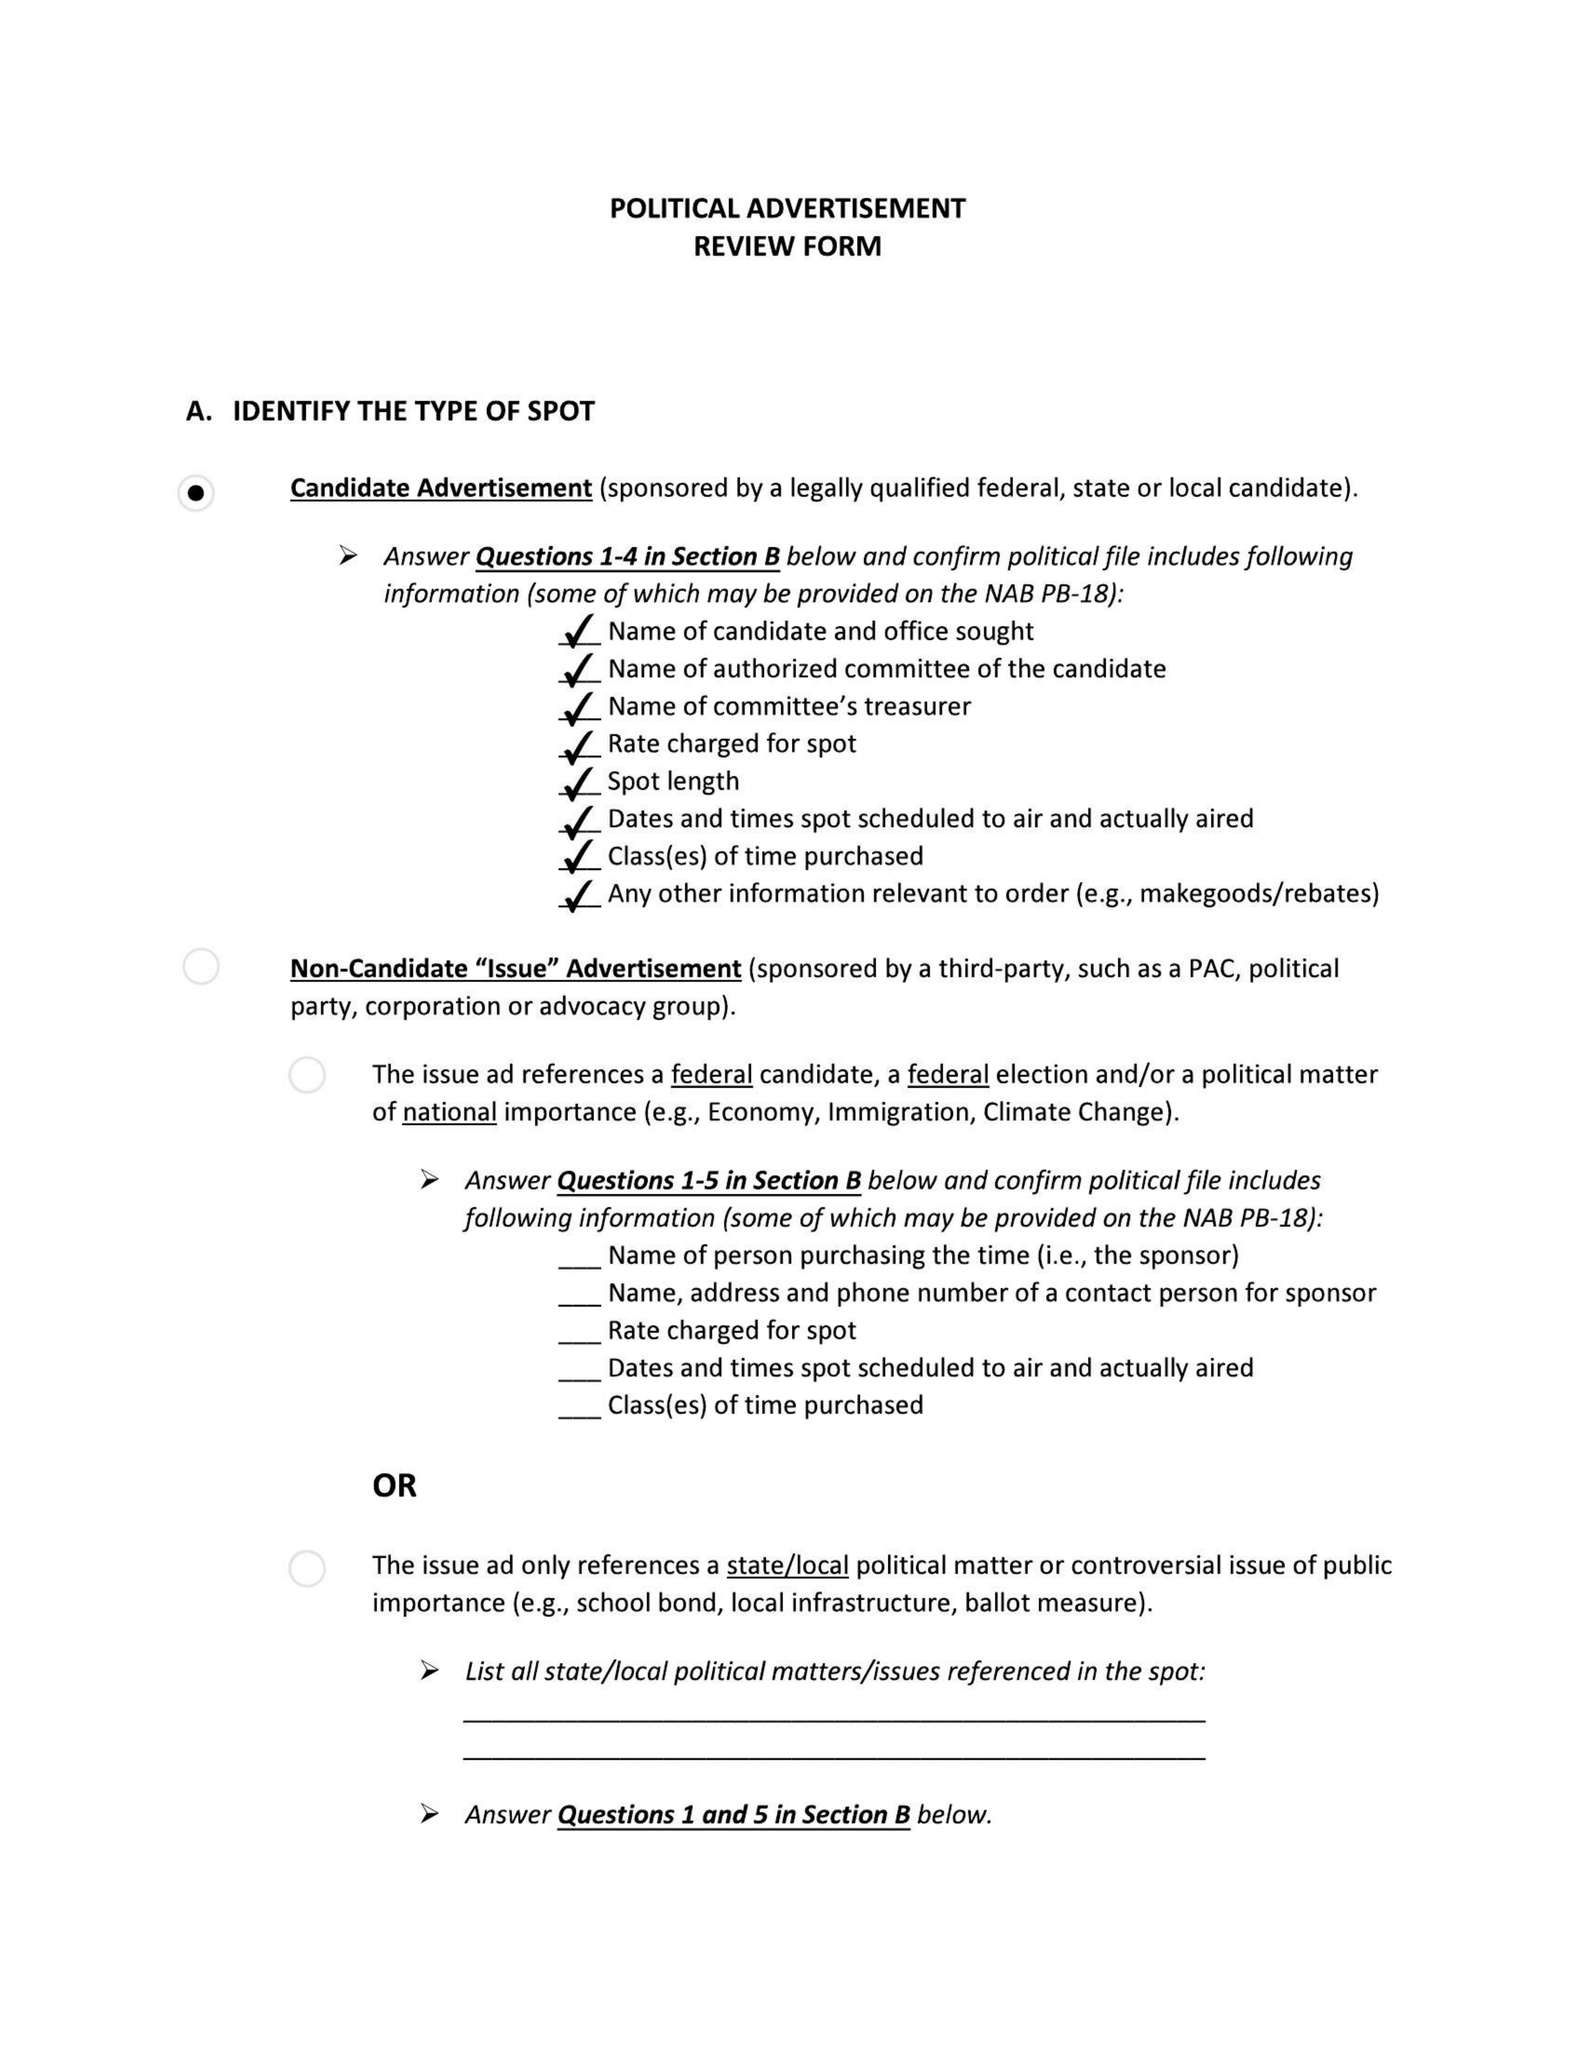What is the value for the gross_amount?
Answer the question using a single word or phrase. None 